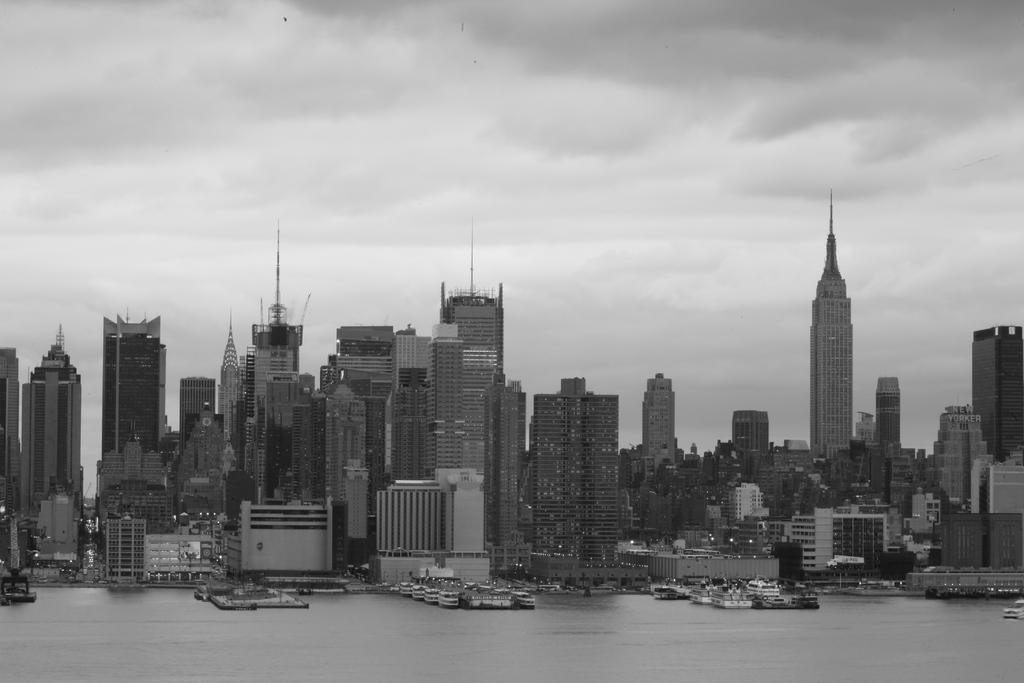What is located in the center of the image? There are buildings in the center of the image. What is at the bottom of the image? There is water at the bottom of the image. What can be seen floating on the water? Boats are visible on the water. What is visible in the background of the image? There is sky visible in the background of the image. Where are the spiders located in the image? There are no spiders present in the image. What type of field can be seen in the image? There is no field present in the image. 